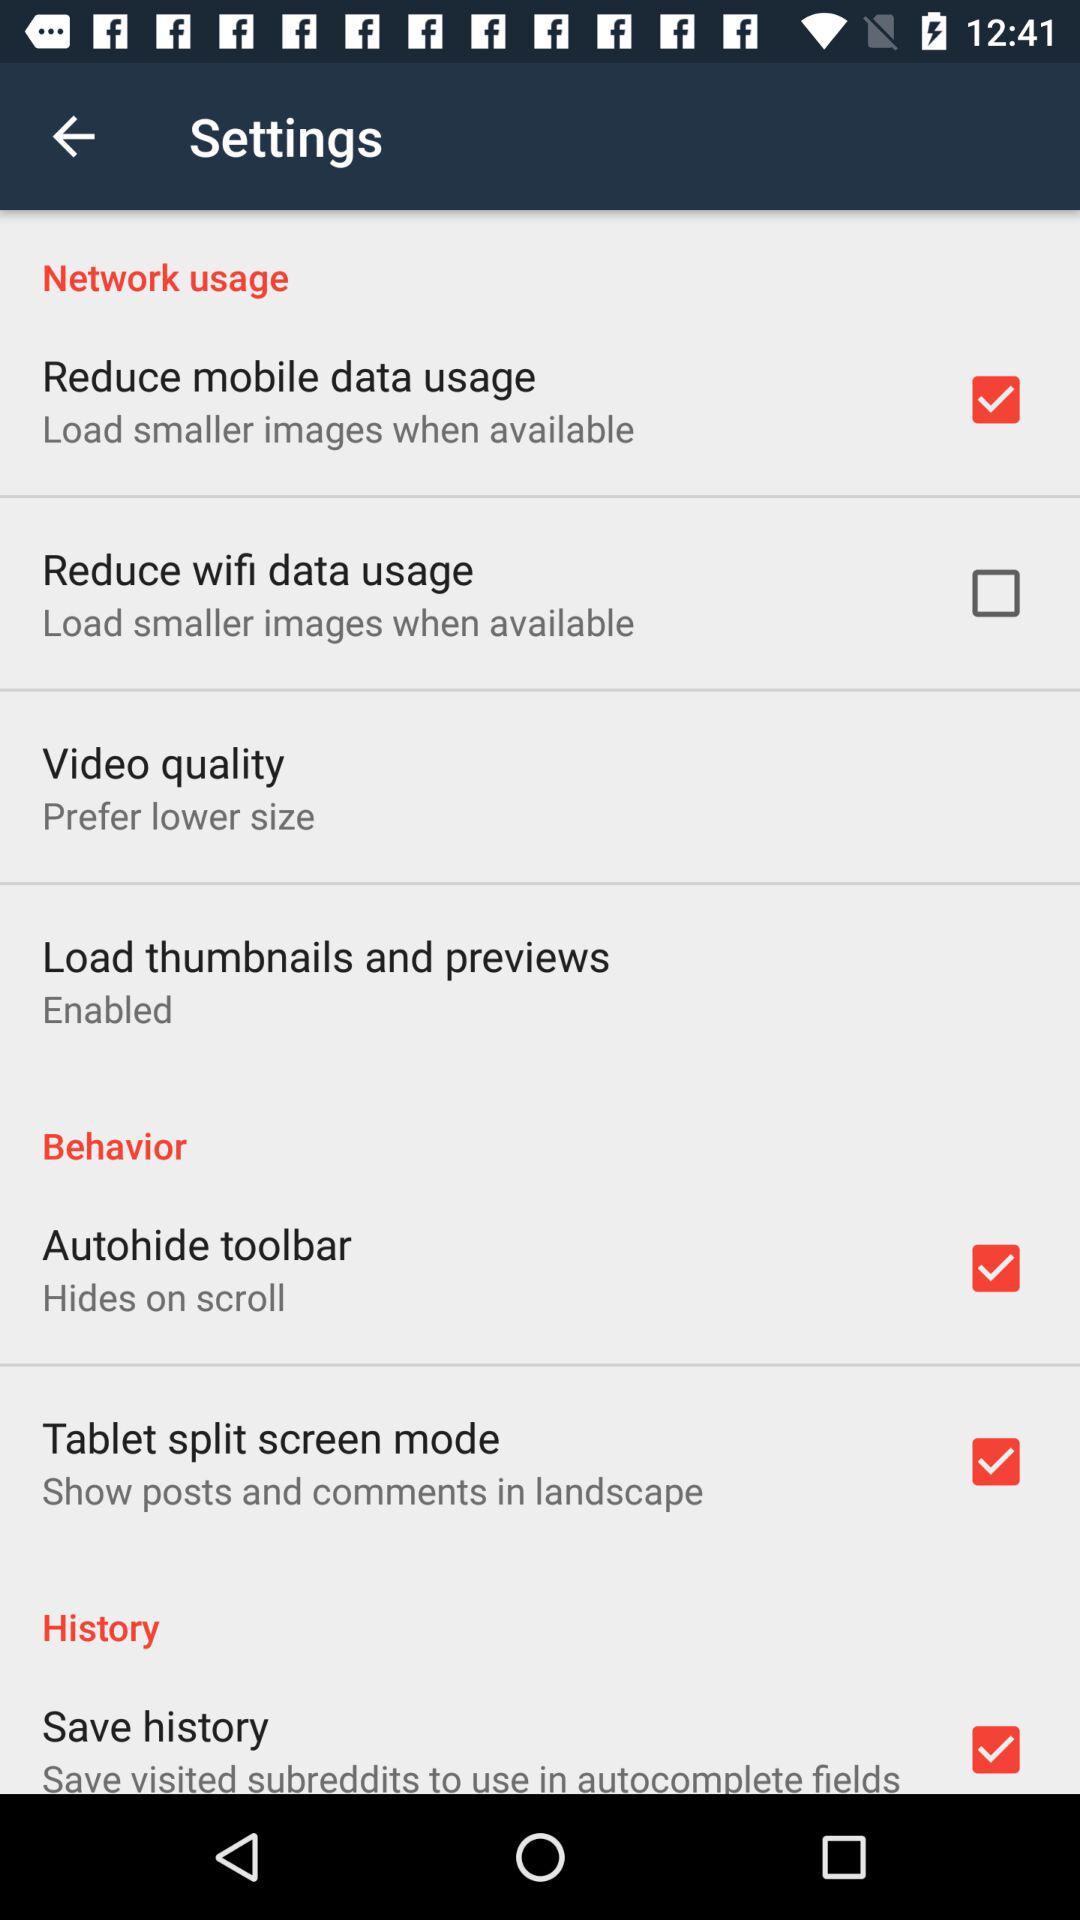What is the status of the "Load thumbnails and previews"? The status is "Enabled". 